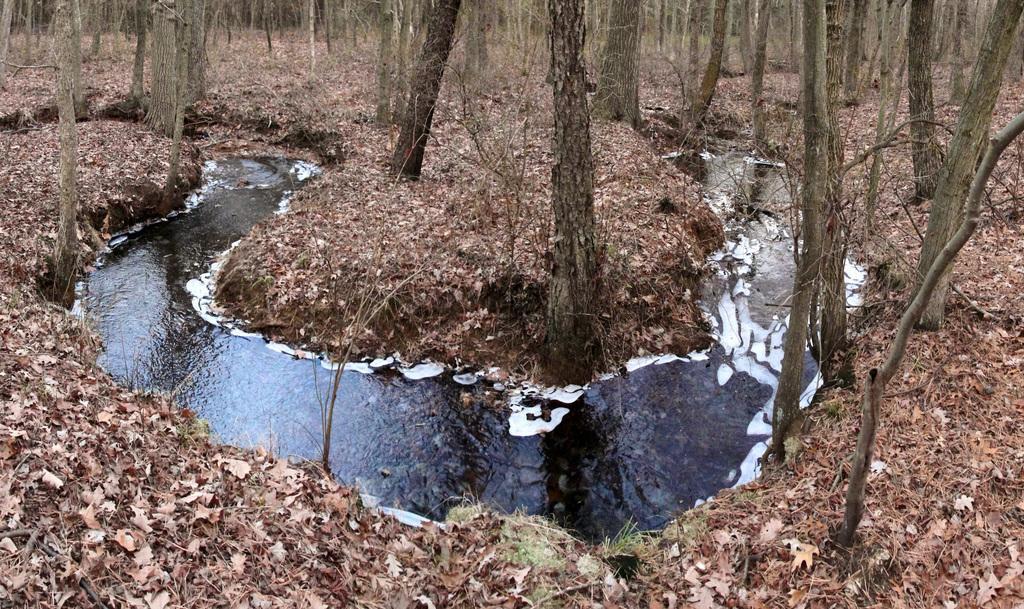Could you give a brief overview of what you see in this image? In this picture we can see water and few trees, and we can find leaves on the ground. 